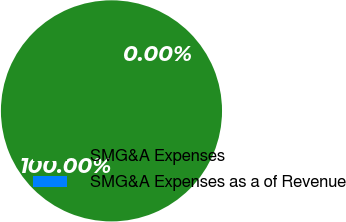Convert chart. <chart><loc_0><loc_0><loc_500><loc_500><pie_chart><fcel>SMG&A Expenses<fcel>SMG&A Expenses as a of Revenue<nl><fcel>100.0%<fcel>0.0%<nl></chart> 